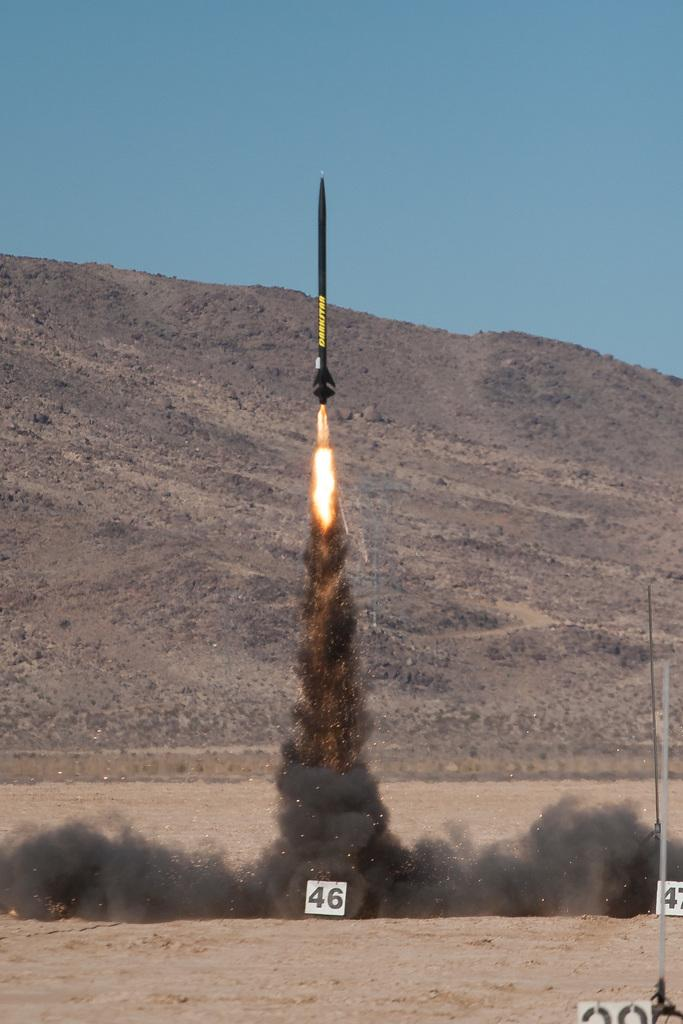What can be seen in the foreground of the picture? There are number boards and sand in the foreground of the picture. What is happening in the center of the picture? A missile is being launched in the center of the picture. What is visible in the background of the picture? There is a hill and the sky in the background of the picture. Can you see any giants walking near the hill in the background of the image? There are no giants present in the image; it features a missile launch and number boards in the foreground. Is there a lake visible in the background of the image? There is no lake present in the image; it features a hill and the sky in the background. 